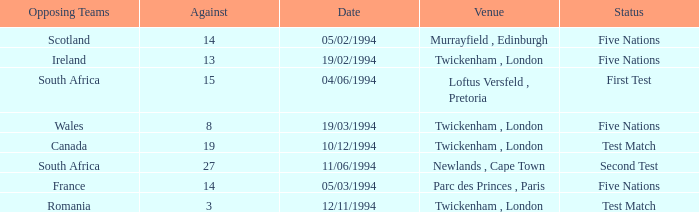How many against have a status of first test? 1.0. 